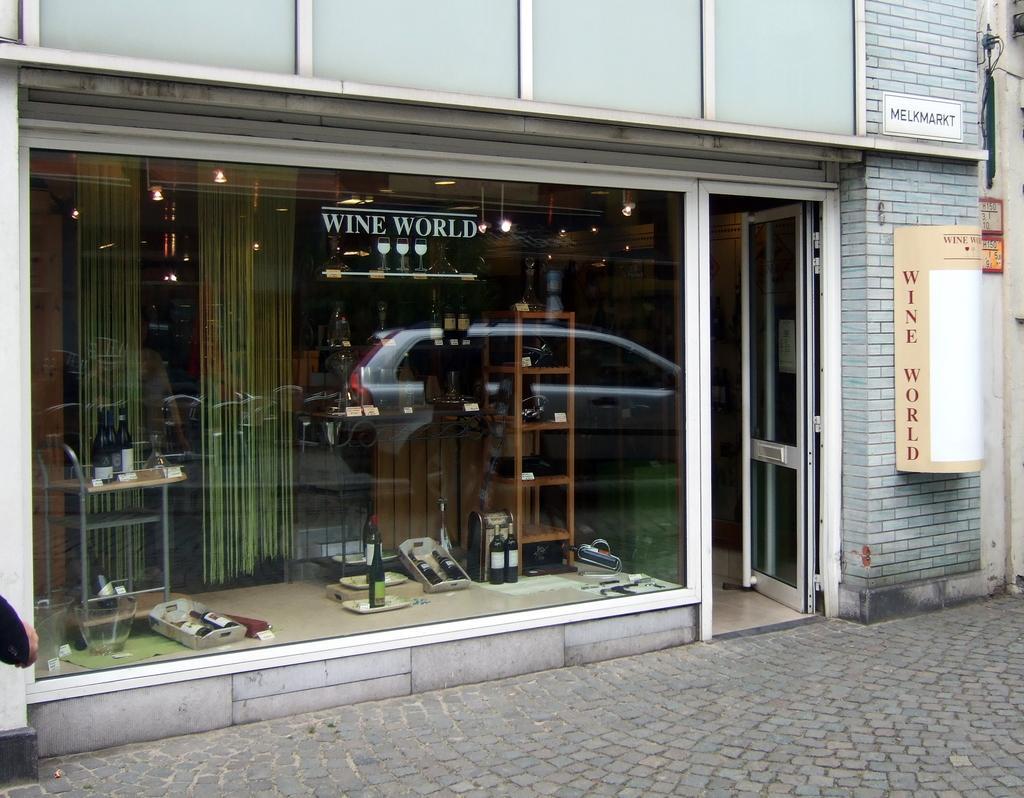Could you give a brief overview of what you see in this image? In this image I can see the store. In side the store I can see few bottles and few wooden objects. In front I can see the glass wall. 